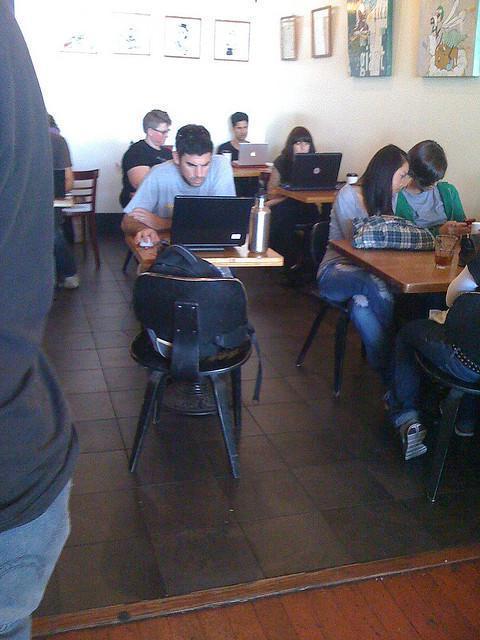How many chairs are in the photo?
Give a very brief answer. 3. How many laptops can you see?
Give a very brief answer. 1. How many backpacks are there?
Give a very brief answer. 2. How many people are visible?
Give a very brief answer. 7. How many clock faces are on this structure?
Give a very brief answer. 0. 